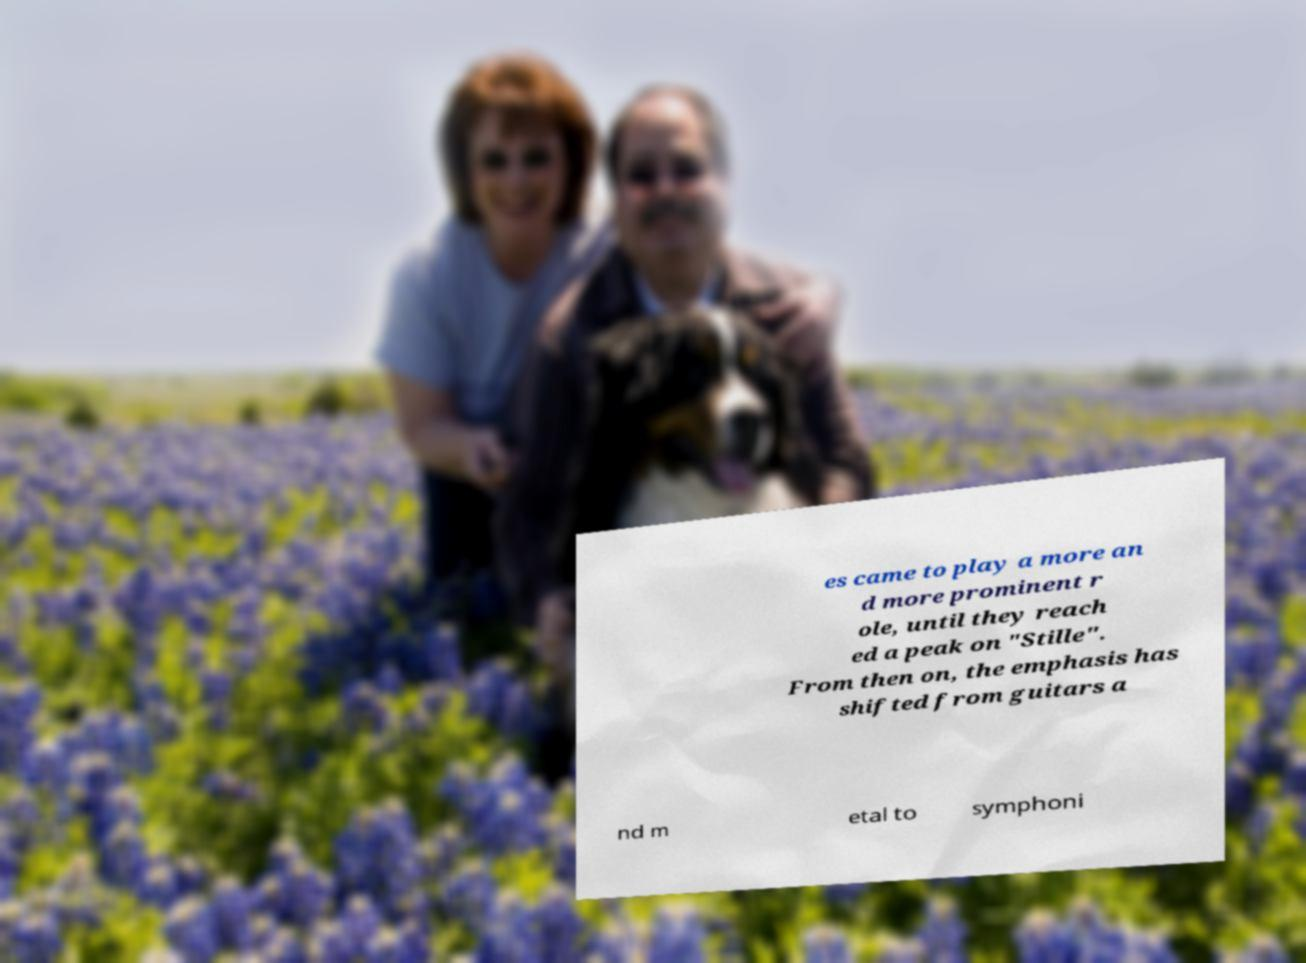There's text embedded in this image that I need extracted. Can you transcribe it verbatim? es came to play a more an d more prominent r ole, until they reach ed a peak on "Stille". From then on, the emphasis has shifted from guitars a nd m etal to symphoni 